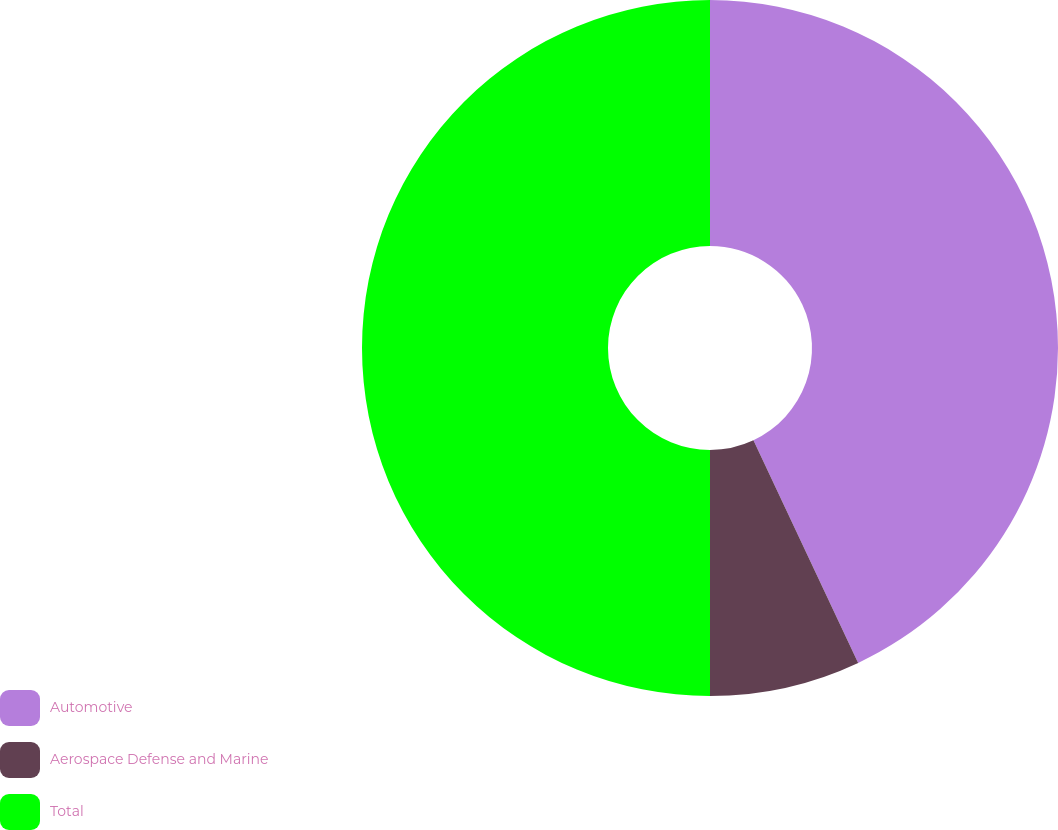Convert chart. <chart><loc_0><loc_0><loc_500><loc_500><pie_chart><fcel>Automotive<fcel>Aerospace Defense and Marine<fcel>Total<nl><fcel>43.0%<fcel>7.0%<fcel>50.0%<nl></chart> 